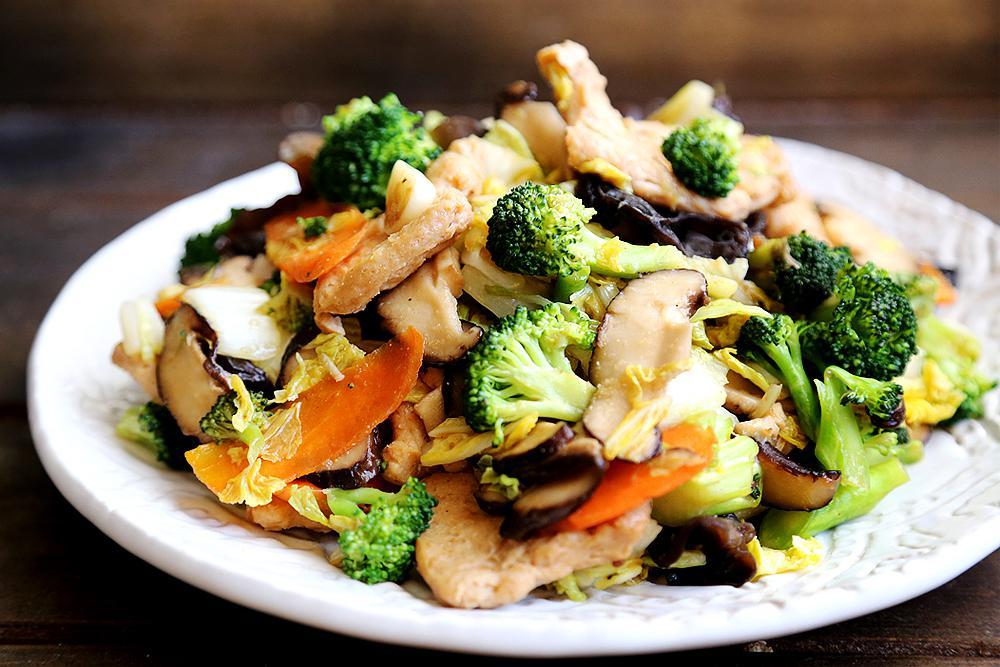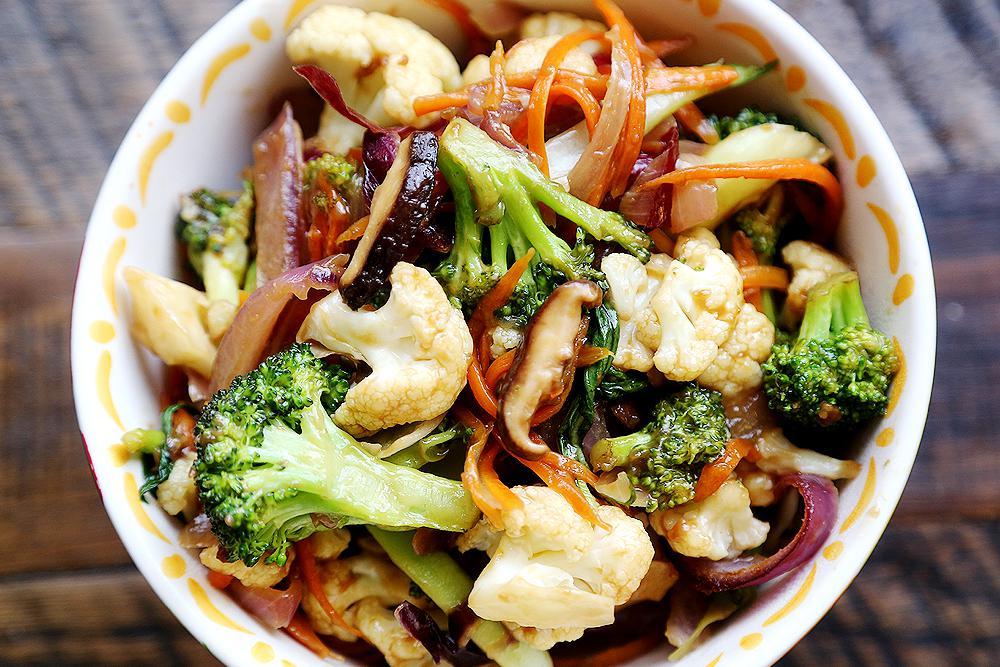The first image is the image on the left, the second image is the image on the right. For the images shown, is this caption "The left and right image contains two white bowl of broccoli and chickens." true? Answer yes or no. Yes. The first image is the image on the left, the second image is the image on the right. Evaluate the accuracy of this statement regarding the images: "A fork is inside the bowl of one of the stir-frys in one image.". Is it true? Answer yes or no. No. 